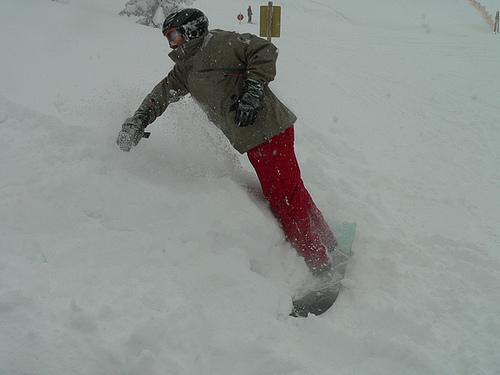Is the person dressed warmly?
Write a very short answer. Yes. Which sport is this?
Quick response, please. Snowboarding. Can the man see through his goggles?
Give a very brief answer. Yes. What color clothes is he wearing?
Give a very brief answer. Green and red. What sport is it?
Quick response, please. Snowboarding. What special task were these pants designed for?
Be succinct. Snowboarding. What sport is this?
Concise answer only. Snowboarding. What does the sky most likely look like over this scene?
Quick response, please. Cloudy. 